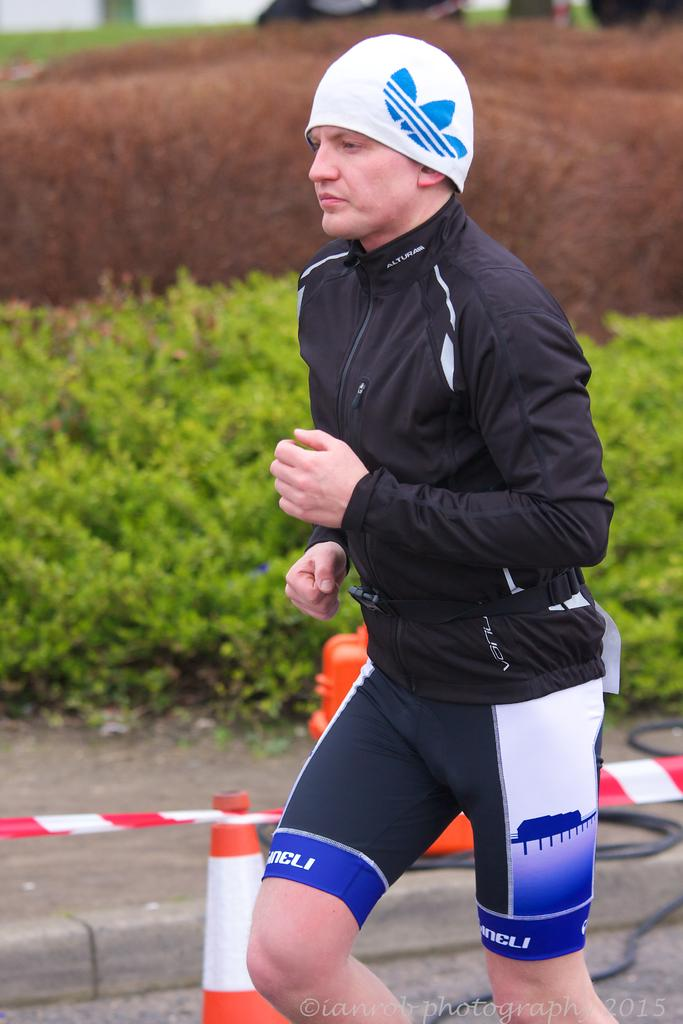What is the person in the image doing? The person in the image is running. What can be seen in the background of the image? There are plants visible in the image. What objects are present that might be used to control or direct traffic or movement? There are barricades in the image. What type of advice can be heard being given in the image? There is no indication in the image that any advice is being given, so it cannot be determined from the picture. 